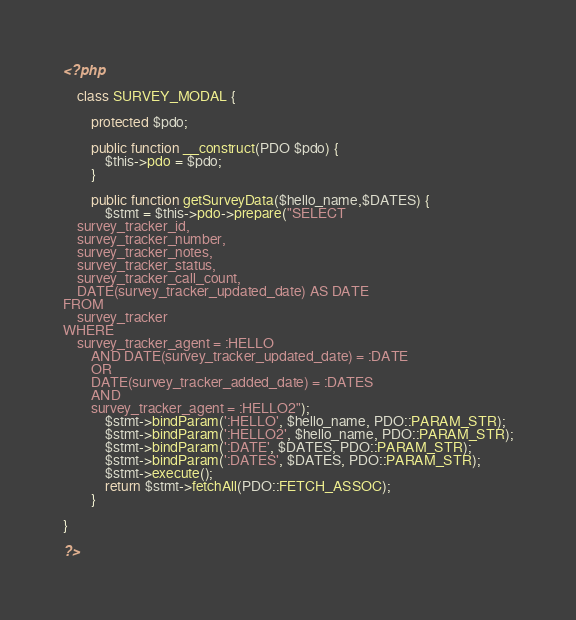Convert code to text. <code><loc_0><loc_0><loc_500><loc_500><_PHP_><?php

    class SURVEY_MODAL {

        protected $pdo;

        public function __construct(PDO $pdo) {
            $this->pdo = $pdo;
        }

        public function getSurveyData($hello_name,$DATES) {
            $stmt = $this->pdo->prepare("SELECT 
    survey_tracker_id,
    survey_tracker_number,
    survey_tracker_notes,
    survey_tracker_status,
    survey_tracker_call_count,
    DATE(survey_tracker_updated_date) AS DATE
FROM
    survey_tracker
WHERE
    survey_tracker_agent = :HELLO
        AND DATE(survey_tracker_updated_date) = :DATE
        OR
        DATE(survey_tracker_added_date) = :DATES
        AND
        survey_tracker_agent = :HELLO2");
            $stmt->bindParam(':HELLO', $hello_name, PDO::PARAM_STR);
            $stmt->bindParam(':HELLO2', $hello_name, PDO::PARAM_STR);
            $stmt->bindParam(':DATE', $DATES, PDO::PARAM_STR);
            $stmt->bindParam(':DATES', $DATES, PDO::PARAM_STR);
            $stmt->execute();
            return $stmt->fetchAll(PDO::FETCH_ASSOC);
        }

}

?></code> 